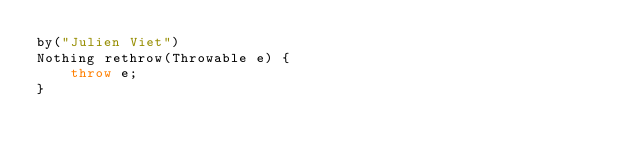<code> <loc_0><loc_0><loc_500><loc_500><_Ceylon_>by("Julien Viet")
Nothing rethrow(Throwable e) {
    throw e;
}
</code> 